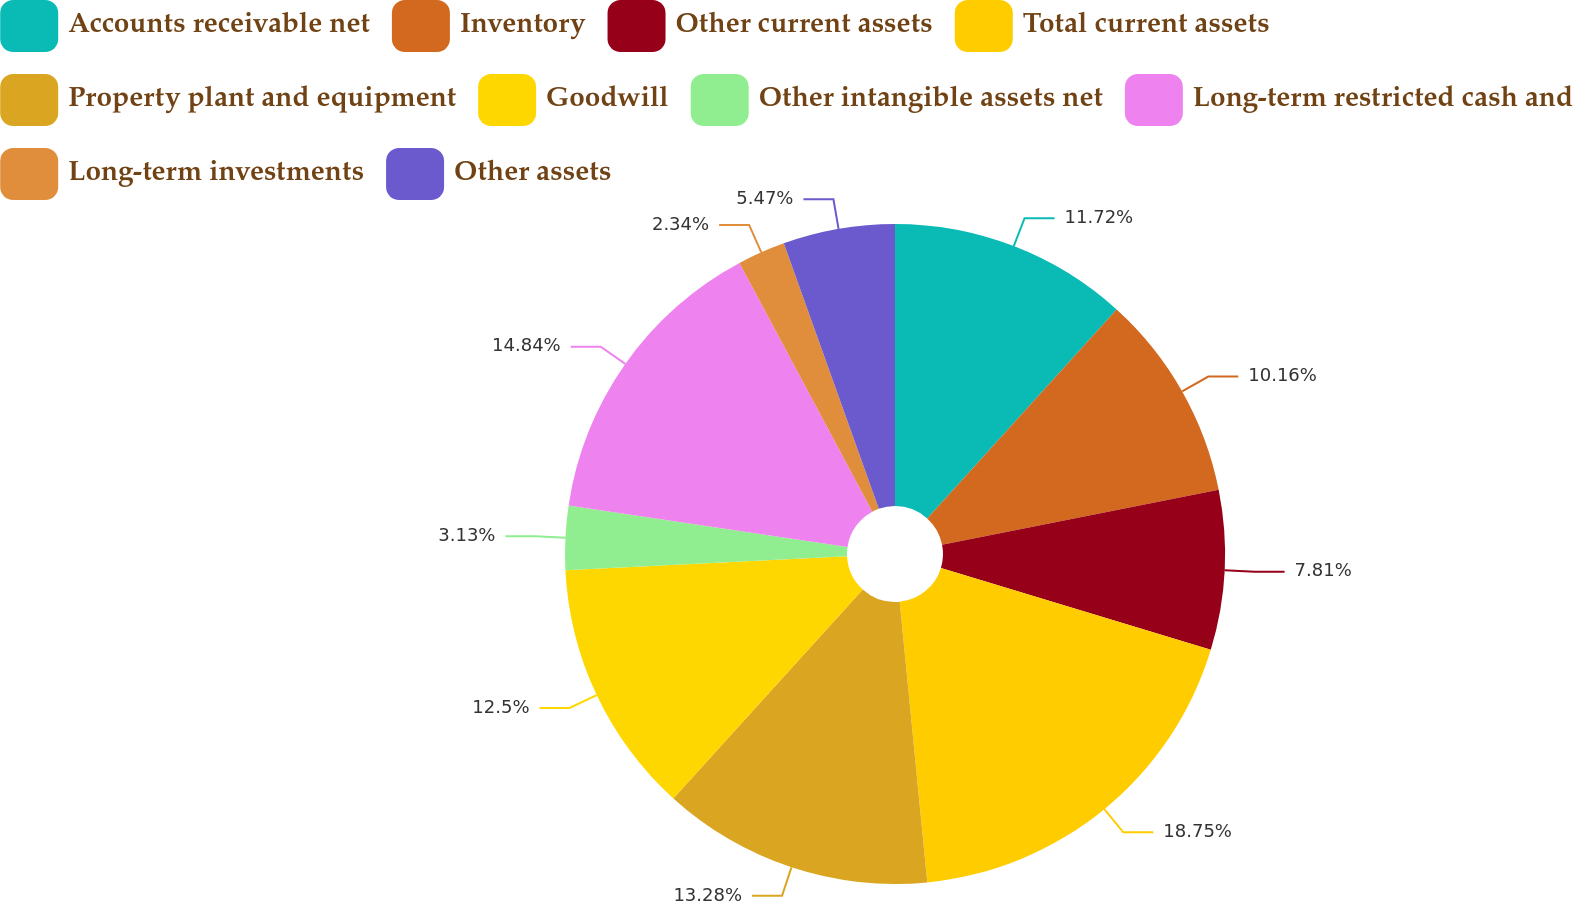<chart> <loc_0><loc_0><loc_500><loc_500><pie_chart><fcel>Accounts receivable net<fcel>Inventory<fcel>Other current assets<fcel>Total current assets<fcel>Property plant and equipment<fcel>Goodwill<fcel>Other intangible assets net<fcel>Long-term restricted cash and<fcel>Long-term investments<fcel>Other assets<nl><fcel>11.72%<fcel>10.16%<fcel>7.81%<fcel>18.75%<fcel>13.28%<fcel>12.5%<fcel>3.13%<fcel>14.84%<fcel>2.34%<fcel>5.47%<nl></chart> 